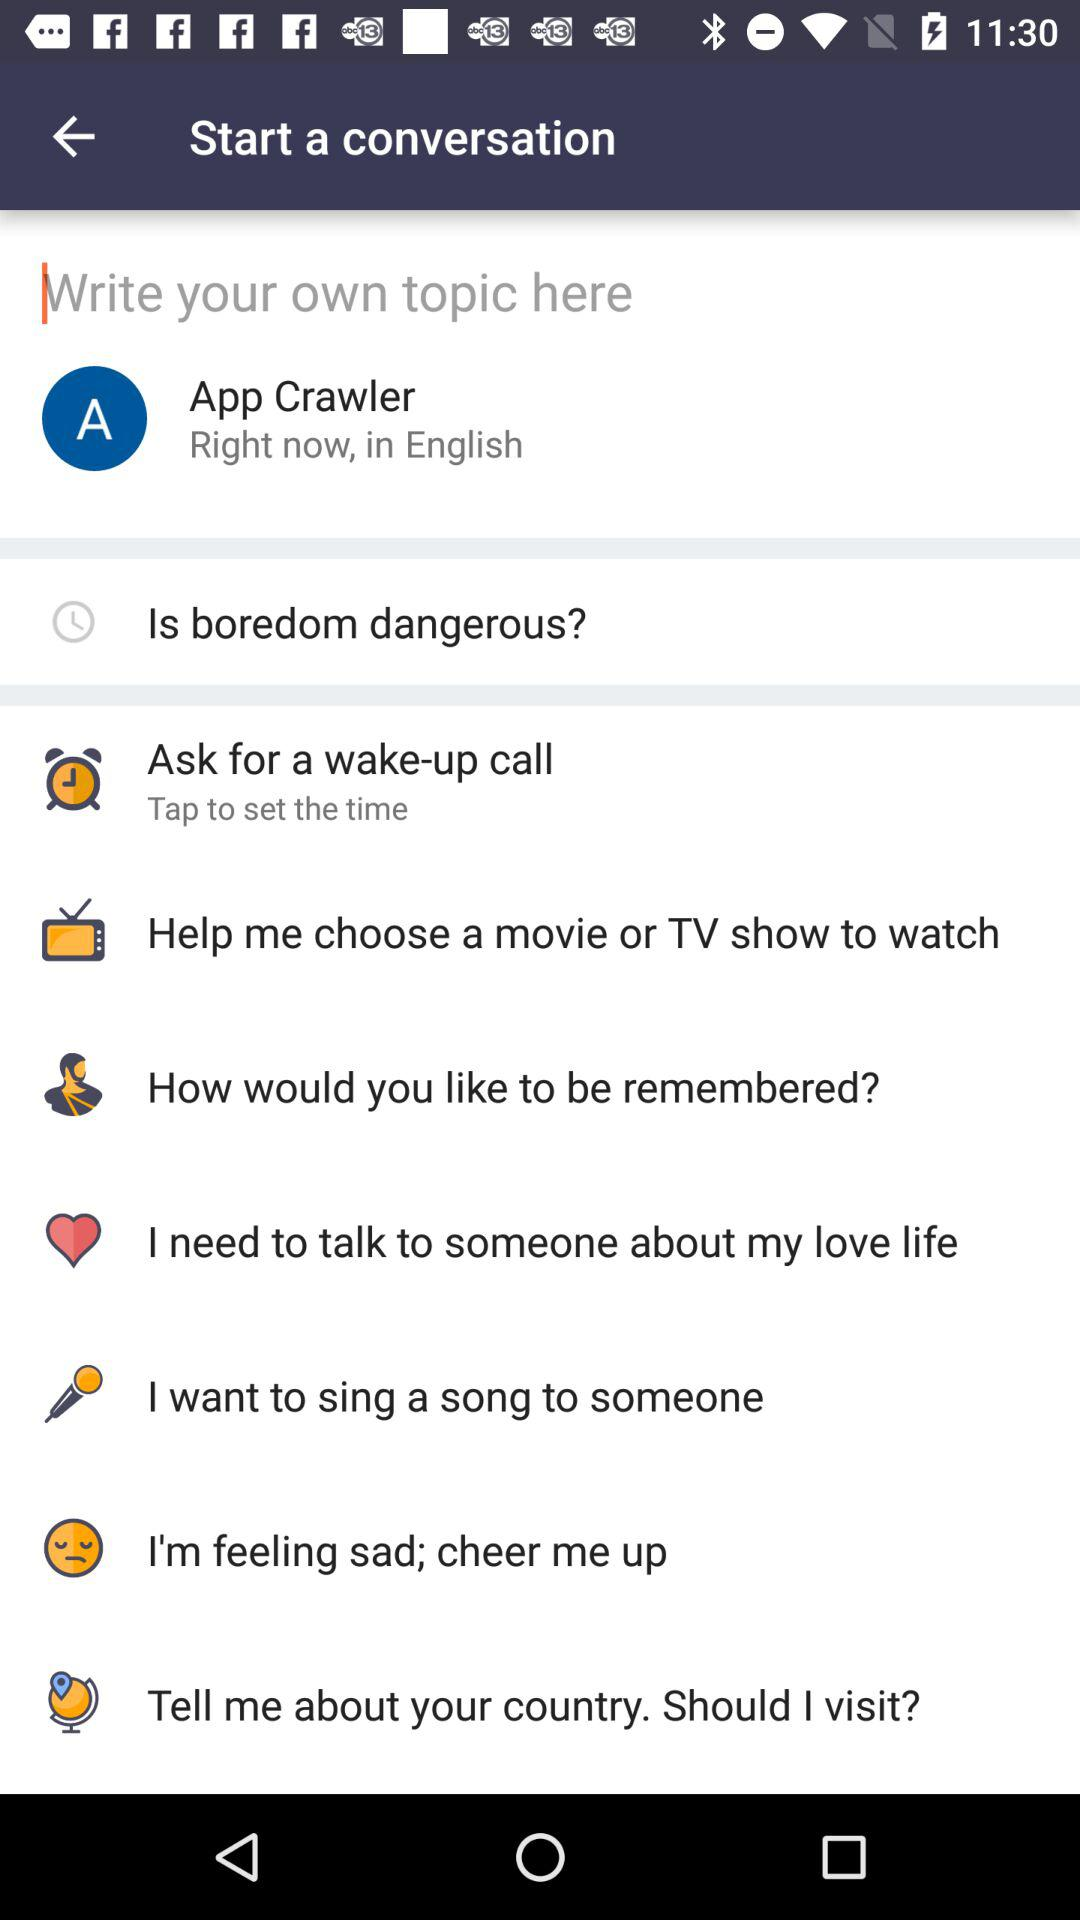What is the user name? The user name is App Crawler. 